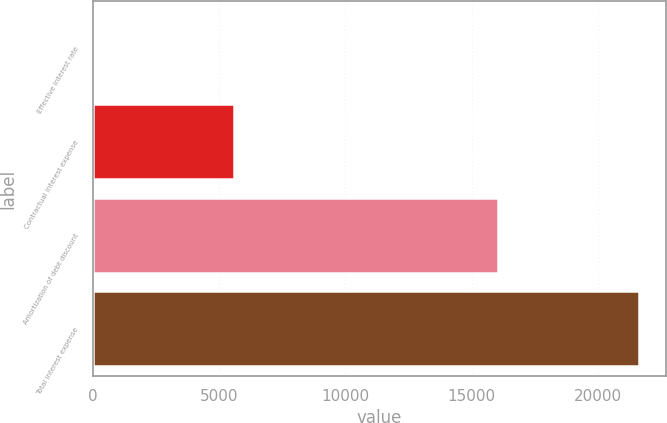Convert chart. <chart><loc_0><loc_0><loc_500><loc_500><bar_chart><fcel>Effective interest rate<fcel>Contractual interest expense<fcel>Amortization of debt discount<fcel>Total interest expense<nl><fcel>6.3<fcel>5579<fcel>16055<fcel>21634<nl></chart> 